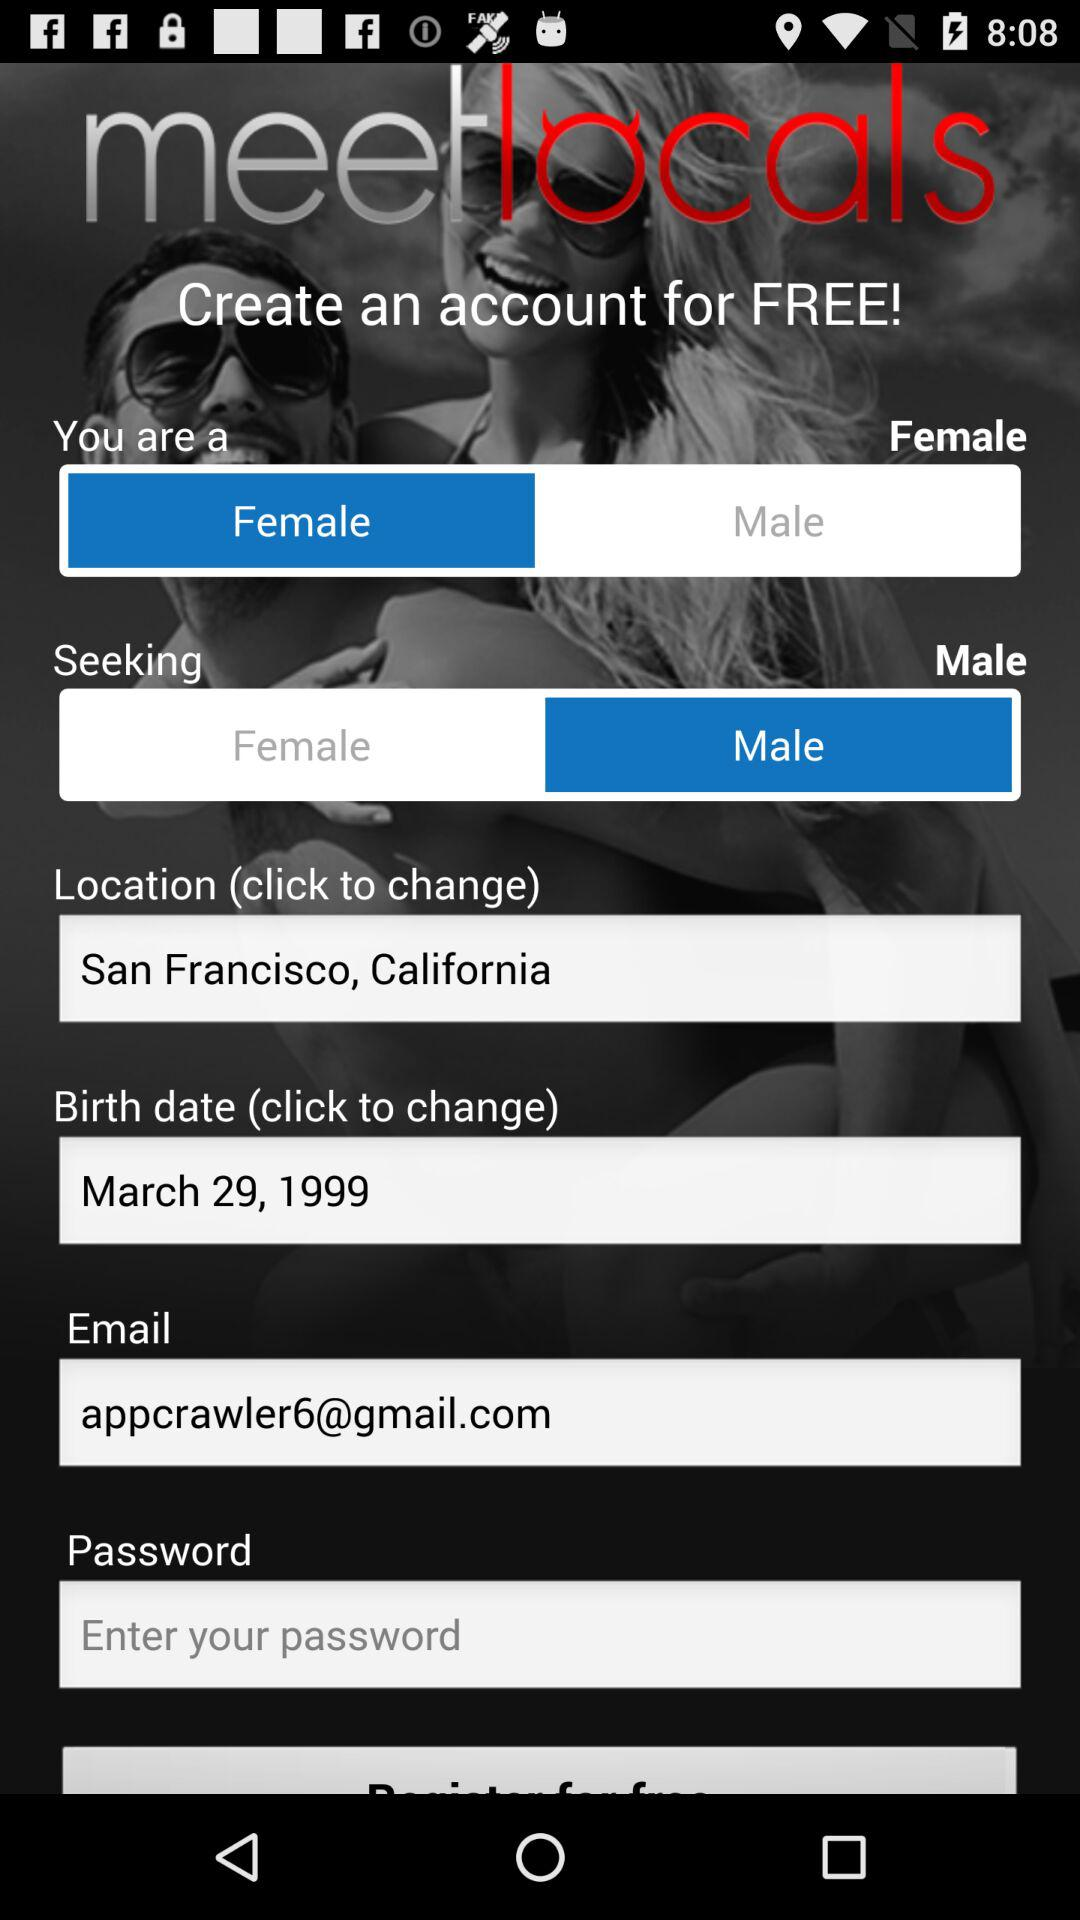What is the application name? The application name is "meet locals". 